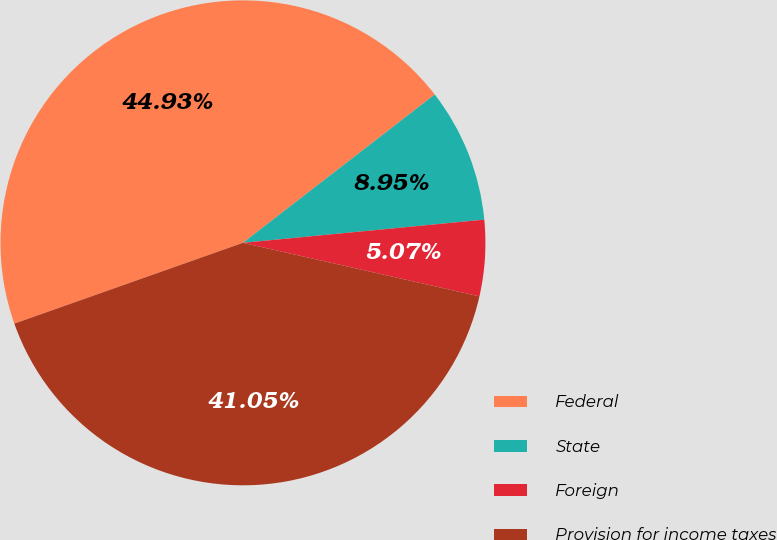Convert chart to OTSL. <chart><loc_0><loc_0><loc_500><loc_500><pie_chart><fcel>Federal<fcel>State<fcel>Foreign<fcel>Provision for income taxes<nl><fcel>44.93%<fcel>8.95%<fcel>5.07%<fcel>41.05%<nl></chart> 